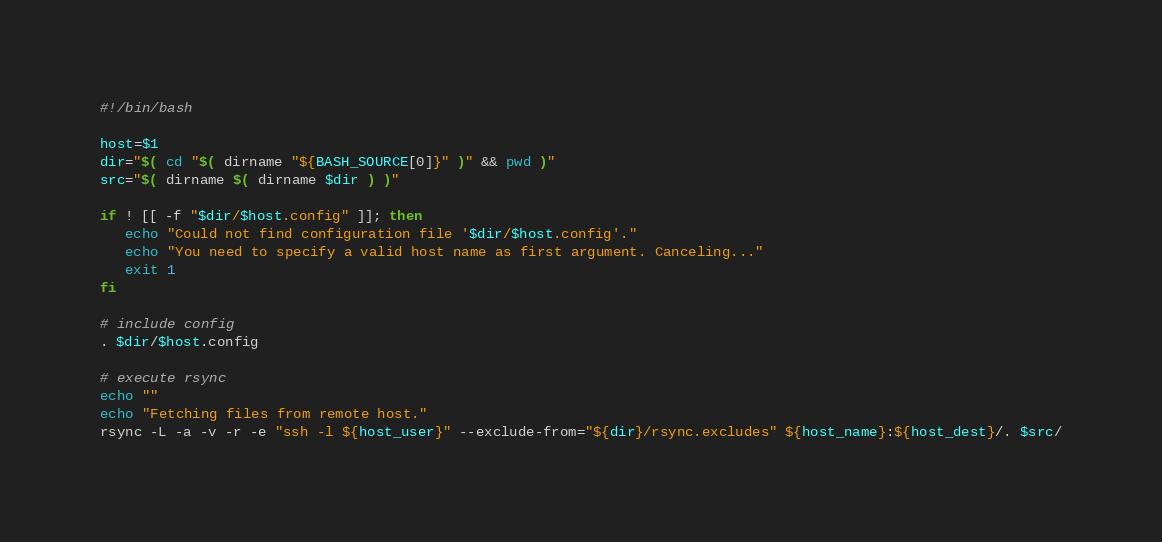<code> <loc_0><loc_0><loc_500><loc_500><_Bash_>#!/bin/bash

host=$1
dir="$( cd "$( dirname "${BASH_SOURCE[0]}" )" && pwd )"
src="$( dirname $( dirname $dir ) )"

if ! [[ -f "$dir/$host.config" ]]; then
   echo "Could not find configuration file '$dir/$host.config'."
   echo "You need to specify a valid host name as first argument. Canceling..."
   exit 1
fi

# include config
. $dir/$host.config

# execute rsync
echo ""
echo "Fetching files from remote host."
rsync -L -a -v -r -e "ssh -l ${host_user}" --exclude-from="${dir}/rsync.excludes" ${host_name}:${host_dest}/. $src/
</code> 